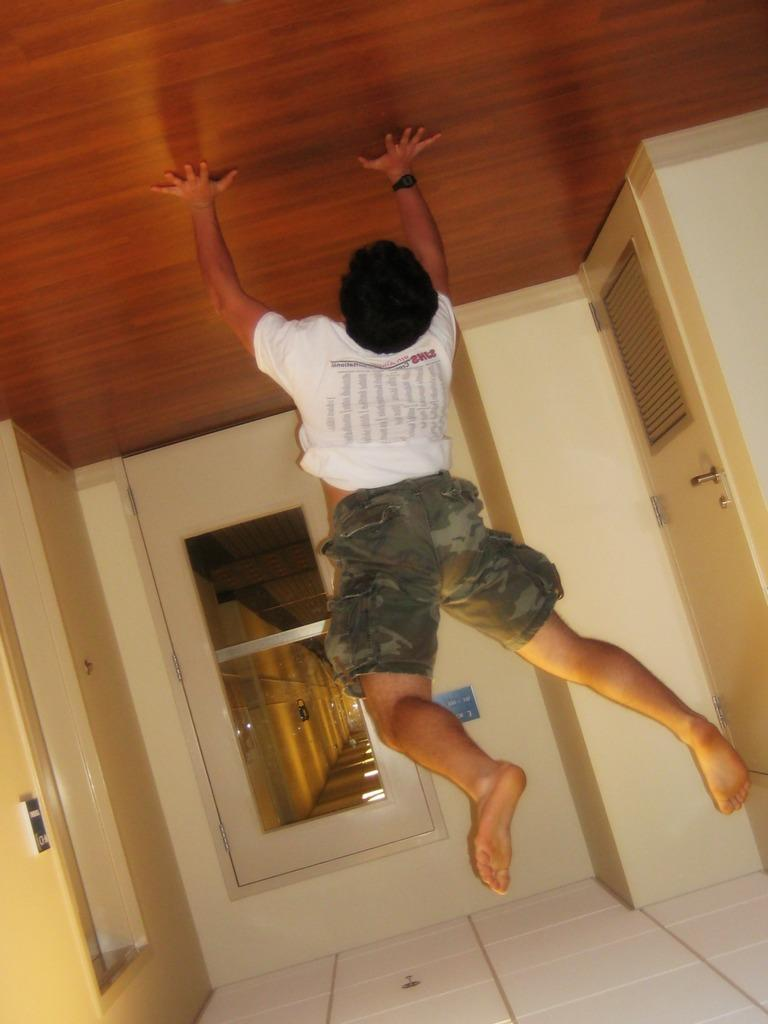Who or what is present in the image? There is a person in the image. What architectural feature can be seen in the image? There are doors in the image. Can you describe the object on the wall at the left side of the image? Unfortunately, the provided facts do not give enough information to describe the object on the wall. What type of song is being sung by the person in the image? There is no indication in the image that the person is singing a song, so it cannot be determined from the picture. 